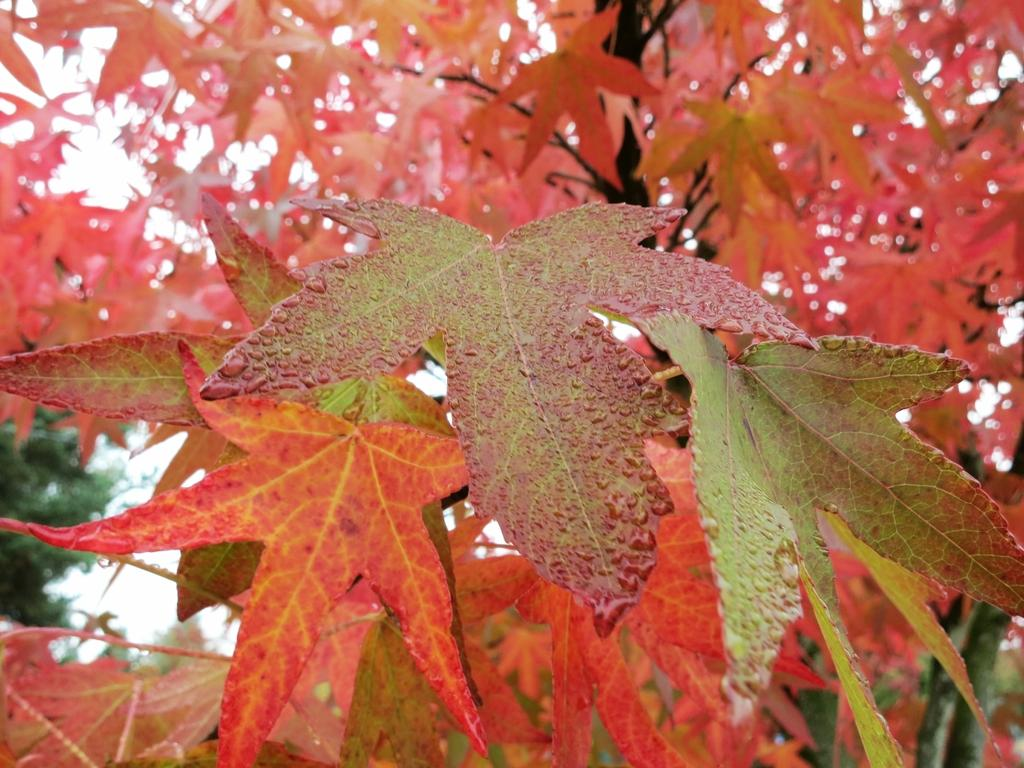What type of vegetation can be seen in the image? There are trees in the image. Can you describe the trees in the image? The provided facts do not give specific details about the trees, so we cannot describe them further. What might be the purpose of the trees in the image? The trees in the image could be providing shade, serving as a habitat for wildlife, or simply adding visual interest to the scene. What type of feast is being held under the trees in the image? There is no feast present in the image; it only features trees. What act of kindness is being performed by the trees in the image? The trees in the image are not performing any act of kindness, as they are inanimate objects and do not have the ability to perform actions or exhibit emotions. 